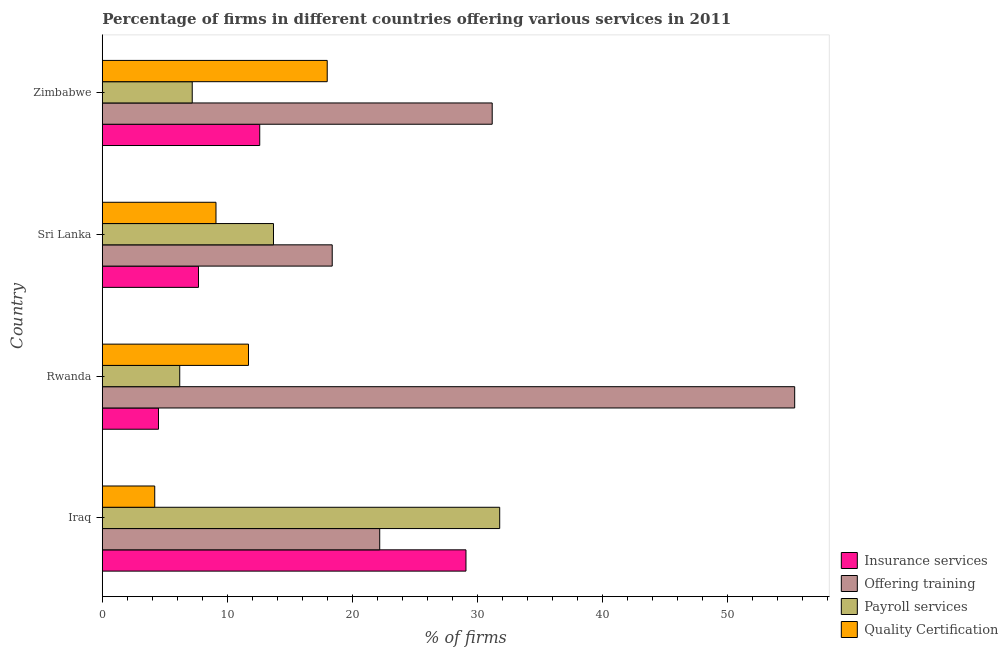How many groups of bars are there?
Ensure brevity in your answer.  4. Are the number of bars per tick equal to the number of legend labels?
Your answer should be compact. Yes. Are the number of bars on each tick of the Y-axis equal?
Ensure brevity in your answer.  Yes. How many bars are there on the 3rd tick from the bottom?
Provide a short and direct response. 4. What is the label of the 3rd group of bars from the top?
Offer a very short reply. Rwanda. Across all countries, what is the maximum percentage of firms offering quality certification?
Provide a succinct answer. 18. Across all countries, what is the minimum percentage of firms offering quality certification?
Offer a very short reply. 4.2. In which country was the percentage of firms offering training maximum?
Keep it short and to the point. Rwanda. In which country was the percentage of firms offering payroll services minimum?
Your answer should be very brief. Rwanda. What is the total percentage of firms offering quality certification in the graph?
Give a very brief answer. 43. What is the difference between the percentage of firms offering payroll services in Sri Lanka and that in Zimbabwe?
Offer a terse response. 6.5. What is the difference between the percentage of firms offering insurance services in Sri Lanka and the percentage of firms offering quality certification in Iraq?
Keep it short and to the point. 3.5. What is the average percentage of firms offering insurance services per country?
Make the answer very short. 13.47. In how many countries, is the percentage of firms offering payroll services greater than 46 %?
Provide a succinct answer. 0. What is the ratio of the percentage of firms offering payroll services in Iraq to that in Rwanda?
Provide a short and direct response. 5.13. Is the difference between the percentage of firms offering quality certification in Sri Lanka and Zimbabwe greater than the difference between the percentage of firms offering payroll services in Sri Lanka and Zimbabwe?
Your answer should be compact. No. What is the difference between the highest and the lowest percentage of firms offering insurance services?
Keep it short and to the point. 24.6. In how many countries, is the percentage of firms offering payroll services greater than the average percentage of firms offering payroll services taken over all countries?
Offer a terse response. 1. Is the sum of the percentage of firms offering payroll services in Rwanda and Sri Lanka greater than the maximum percentage of firms offering training across all countries?
Offer a very short reply. No. Is it the case that in every country, the sum of the percentage of firms offering payroll services and percentage of firms offering training is greater than the sum of percentage of firms offering insurance services and percentage of firms offering quality certification?
Offer a very short reply. Yes. What does the 3rd bar from the top in Iraq represents?
Your answer should be very brief. Offering training. What does the 1st bar from the bottom in Rwanda represents?
Offer a terse response. Insurance services. Is it the case that in every country, the sum of the percentage of firms offering insurance services and percentage of firms offering training is greater than the percentage of firms offering payroll services?
Give a very brief answer. Yes. How many bars are there?
Offer a terse response. 16. Are all the bars in the graph horizontal?
Your answer should be compact. Yes. How many countries are there in the graph?
Offer a very short reply. 4. Does the graph contain any zero values?
Keep it short and to the point. No. Does the graph contain grids?
Give a very brief answer. No. Where does the legend appear in the graph?
Your answer should be compact. Bottom right. How many legend labels are there?
Offer a terse response. 4. How are the legend labels stacked?
Your response must be concise. Vertical. What is the title of the graph?
Provide a succinct answer. Percentage of firms in different countries offering various services in 2011. What is the label or title of the X-axis?
Provide a short and direct response. % of firms. What is the label or title of the Y-axis?
Your answer should be very brief. Country. What is the % of firms of Insurance services in Iraq?
Offer a very short reply. 29.1. What is the % of firms of Payroll services in Iraq?
Give a very brief answer. 31.8. What is the % of firms of Offering training in Rwanda?
Ensure brevity in your answer.  55.4. What is the % of firms of Payroll services in Rwanda?
Keep it short and to the point. 6.2. What is the % of firms in Quality Certification in Rwanda?
Offer a very short reply. 11.7. What is the % of firms of Quality Certification in Sri Lanka?
Provide a short and direct response. 9.1. What is the % of firms of Offering training in Zimbabwe?
Your answer should be compact. 31.2. Across all countries, what is the maximum % of firms in Insurance services?
Your answer should be very brief. 29.1. Across all countries, what is the maximum % of firms of Offering training?
Your answer should be compact. 55.4. Across all countries, what is the maximum % of firms of Payroll services?
Ensure brevity in your answer.  31.8. Across all countries, what is the minimum % of firms of Insurance services?
Offer a terse response. 4.5. Across all countries, what is the minimum % of firms of Offering training?
Provide a succinct answer. 18.4. Across all countries, what is the minimum % of firms of Quality Certification?
Give a very brief answer. 4.2. What is the total % of firms in Insurance services in the graph?
Ensure brevity in your answer.  53.9. What is the total % of firms of Offering training in the graph?
Offer a very short reply. 127.2. What is the total % of firms of Payroll services in the graph?
Offer a very short reply. 58.9. What is the difference between the % of firms in Insurance services in Iraq and that in Rwanda?
Your answer should be very brief. 24.6. What is the difference between the % of firms in Offering training in Iraq and that in Rwanda?
Provide a short and direct response. -33.2. What is the difference between the % of firms in Payroll services in Iraq and that in Rwanda?
Give a very brief answer. 25.6. What is the difference between the % of firms in Insurance services in Iraq and that in Sri Lanka?
Ensure brevity in your answer.  21.4. What is the difference between the % of firms in Offering training in Iraq and that in Sri Lanka?
Make the answer very short. 3.8. What is the difference between the % of firms in Payroll services in Iraq and that in Sri Lanka?
Offer a terse response. 18.1. What is the difference between the % of firms of Offering training in Iraq and that in Zimbabwe?
Offer a very short reply. -9. What is the difference between the % of firms in Payroll services in Iraq and that in Zimbabwe?
Ensure brevity in your answer.  24.6. What is the difference between the % of firms in Insurance services in Rwanda and that in Zimbabwe?
Make the answer very short. -8.1. What is the difference between the % of firms of Offering training in Rwanda and that in Zimbabwe?
Your response must be concise. 24.2. What is the difference between the % of firms in Payroll services in Rwanda and that in Zimbabwe?
Provide a succinct answer. -1. What is the difference between the % of firms of Quality Certification in Rwanda and that in Zimbabwe?
Your response must be concise. -6.3. What is the difference between the % of firms in Insurance services in Sri Lanka and that in Zimbabwe?
Ensure brevity in your answer.  -4.9. What is the difference between the % of firms in Payroll services in Sri Lanka and that in Zimbabwe?
Keep it short and to the point. 6.5. What is the difference between the % of firms in Quality Certification in Sri Lanka and that in Zimbabwe?
Give a very brief answer. -8.9. What is the difference between the % of firms in Insurance services in Iraq and the % of firms in Offering training in Rwanda?
Ensure brevity in your answer.  -26.3. What is the difference between the % of firms in Insurance services in Iraq and the % of firms in Payroll services in Rwanda?
Your answer should be compact. 22.9. What is the difference between the % of firms in Payroll services in Iraq and the % of firms in Quality Certification in Rwanda?
Give a very brief answer. 20.1. What is the difference between the % of firms of Insurance services in Iraq and the % of firms of Payroll services in Sri Lanka?
Offer a very short reply. 15.4. What is the difference between the % of firms of Insurance services in Iraq and the % of firms of Quality Certification in Sri Lanka?
Keep it short and to the point. 20. What is the difference between the % of firms in Offering training in Iraq and the % of firms in Quality Certification in Sri Lanka?
Keep it short and to the point. 13.1. What is the difference between the % of firms in Payroll services in Iraq and the % of firms in Quality Certification in Sri Lanka?
Provide a short and direct response. 22.7. What is the difference between the % of firms in Insurance services in Iraq and the % of firms in Payroll services in Zimbabwe?
Make the answer very short. 21.9. What is the difference between the % of firms in Insurance services in Iraq and the % of firms in Quality Certification in Zimbabwe?
Provide a succinct answer. 11.1. What is the difference between the % of firms in Insurance services in Rwanda and the % of firms in Payroll services in Sri Lanka?
Offer a very short reply. -9.2. What is the difference between the % of firms in Offering training in Rwanda and the % of firms in Payroll services in Sri Lanka?
Your answer should be very brief. 41.7. What is the difference between the % of firms in Offering training in Rwanda and the % of firms in Quality Certification in Sri Lanka?
Ensure brevity in your answer.  46.3. What is the difference between the % of firms of Insurance services in Rwanda and the % of firms of Offering training in Zimbabwe?
Make the answer very short. -26.7. What is the difference between the % of firms of Insurance services in Rwanda and the % of firms of Payroll services in Zimbabwe?
Keep it short and to the point. -2.7. What is the difference between the % of firms in Insurance services in Rwanda and the % of firms in Quality Certification in Zimbabwe?
Make the answer very short. -13.5. What is the difference between the % of firms in Offering training in Rwanda and the % of firms in Payroll services in Zimbabwe?
Your answer should be compact. 48.2. What is the difference between the % of firms of Offering training in Rwanda and the % of firms of Quality Certification in Zimbabwe?
Ensure brevity in your answer.  37.4. What is the difference between the % of firms of Payroll services in Rwanda and the % of firms of Quality Certification in Zimbabwe?
Provide a short and direct response. -11.8. What is the difference between the % of firms of Insurance services in Sri Lanka and the % of firms of Offering training in Zimbabwe?
Provide a short and direct response. -23.5. What is the average % of firms of Insurance services per country?
Offer a very short reply. 13.47. What is the average % of firms in Offering training per country?
Make the answer very short. 31.8. What is the average % of firms of Payroll services per country?
Offer a terse response. 14.72. What is the average % of firms of Quality Certification per country?
Ensure brevity in your answer.  10.75. What is the difference between the % of firms in Insurance services and % of firms in Offering training in Iraq?
Keep it short and to the point. 6.9. What is the difference between the % of firms of Insurance services and % of firms of Quality Certification in Iraq?
Provide a short and direct response. 24.9. What is the difference between the % of firms of Offering training and % of firms of Payroll services in Iraq?
Offer a terse response. -9.6. What is the difference between the % of firms of Payroll services and % of firms of Quality Certification in Iraq?
Offer a very short reply. 27.6. What is the difference between the % of firms in Insurance services and % of firms in Offering training in Rwanda?
Provide a succinct answer. -50.9. What is the difference between the % of firms of Offering training and % of firms of Payroll services in Rwanda?
Give a very brief answer. 49.2. What is the difference between the % of firms in Offering training and % of firms in Quality Certification in Rwanda?
Keep it short and to the point. 43.7. What is the difference between the % of firms of Payroll services and % of firms of Quality Certification in Rwanda?
Make the answer very short. -5.5. What is the difference between the % of firms in Offering training and % of firms in Payroll services in Sri Lanka?
Provide a short and direct response. 4.7. What is the difference between the % of firms in Payroll services and % of firms in Quality Certification in Sri Lanka?
Your response must be concise. 4.6. What is the difference between the % of firms in Insurance services and % of firms in Offering training in Zimbabwe?
Offer a terse response. -18.6. What is the difference between the % of firms of Insurance services and % of firms of Payroll services in Zimbabwe?
Make the answer very short. 5.4. What is the difference between the % of firms in Offering training and % of firms in Payroll services in Zimbabwe?
Your response must be concise. 24. What is the difference between the % of firms of Offering training and % of firms of Quality Certification in Zimbabwe?
Offer a very short reply. 13.2. What is the difference between the % of firms of Payroll services and % of firms of Quality Certification in Zimbabwe?
Your answer should be very brief. -10.8. What is the ratio of the % of firms in Insurance services in Iraq to that in Rwanda?
Give a very brief answer. 6.47. What is the ratio of the % of firms in Offering training in Iraq to that in Rwanda?
Provide a succinct answer. 0.4. What is the ratio of the % of firms in Payroll services in Iraq to that in Rwanda?
Your response must be concise. 5.13. What is the ratio of the % of firms in Quality Certification in Iraq to that in Rwanda?
Give a very brief answer. 0.36. What is the ratio of the % of firms of Insurance services in Iraq to that in Sri Lanka?
Ensure brevity in your answer.  3.78. What is the ratio of the % of firms of Offering training in Iraq to that in Sri Lanka?
Your answer should be compact. 1.21. What is the ratio of the % of firms of Payroll services in Iraq to that in Sri Lanka?
Offer a very short reply. 2.32. What is the ratio of the % of firms of Quality Certification in Iraq to that in Sri Lanka?
Your response must be concise. 0.46. What is the ratio of the % of firms of Insurance services in Iraq to that in Zimbabwe?
Your response must be concise. 2.31. What is the ratio of the % of firms in Offering training in Iraq to that in Zimbabwe?
Your answer should be compact. 0.71. What is the ratio of the % of firms of Payroll services in Iraq to that in Zimbabwe?
Your answer should be compact. 4.42. What is the ratio of the % of firms of Quality Certification in Iraq to that in Zimbabwe?
Ensure brevity in your answer.  0.23. What is the ratio of the % of firms of Insurance services in Rwanda to that in Sri Lanka?
Provide a succinct answer. 0.58. What is the ratio of the % of firms of Offering training in Rwanda to that in Sri Lanka?
Give a very brief answer. 3.01. What is the ratio of the % of firms in Payroll services in Rwanda to that in Sri Lanka?
Your answer should be very brief. 0.45. What is the ratio of the % of firms in Insurance services in Rwanda to that in Zimbabwe?
Your answer should be very brief. 0.36. What is the ratio of the % of firms in Offering training in Rwanda to that in Zimbabwe?
Keep it short and to the point. 1.78. What is the ratio of the % of firms in Payroll services in Rwanda to that in Zimbabwe?
Your answer should be compact. 0.86. What is the ratio of the % of firms in Quality Certification in Rwanda to that in Zimbabwe?
Provide a short and direct response. 0.65. What is the ratio of the % of firms in Insurance services in Sri Lanka to that in Zimbabwe?
Keep it short and to the point. 0.61. What is the ratio of the % of firms of Offering training in Sri Lanka to that in Zimbabwe?
Make the answer very short. 0.59. What is the ratio of the % of firms of Payroll services in Sri Lanka to that in Zimbabwe?
Your response must be concise. 1.9. What is the ratio of the % of firms in Quality Certification in Sri Lanka to that in Zimbabwe?
Give a very brief answer. 0.51. What is the difference between the highest and the second highest % of firms in Insurance services?
Keep it short and to the point. 16.5. What is the difference between the highest and the second highest % of firms in Offering training?
Give a very brief answer. 24.2. What is the difference between the highest and the lowest % of firms of Insurance services?
Keep it short and to the point. 24.6. What is the difference between the highest and the lowest % of firms of Payroll services?
Your response must be concise. 25.6. What is the difference between the highest and the lowest % of firms of Quality Certification?
Your answer should be very brief. 13.8. 